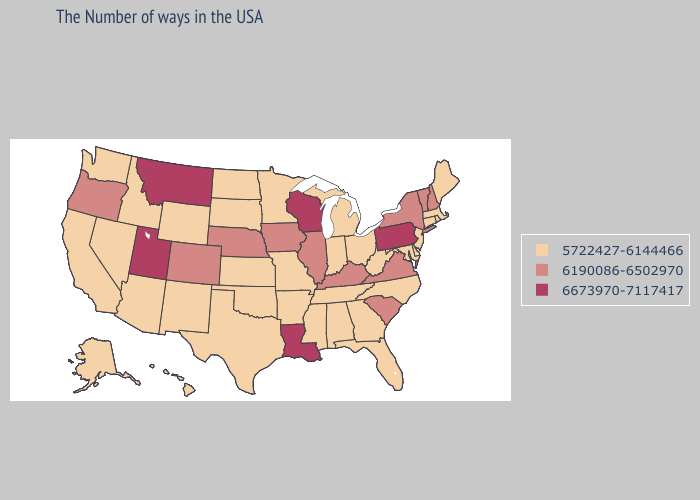What is the value of Oklahoma?
Concise answer only. 5722427-6144466. Name the states that have a value in the range 6190086-6502970?
Write a very short answer. New Hampshire, Vermont, New York, Virginia, South Carolina, Kentucky, Illinois, Iowa, Nebraska, Colorado, Oregon. Does Idaho have a lower value than Rhode Island?
Concise answer only. No. Does Iowa have the lowest value in the USA?
Concise answer only. No. Among the states that border Tennessee , does Virginia have the highest value?
Answer briefly. Yes. Does the first symbol in the legend represent the smallest category?
Keep it brief. Yes. Name the states that have a value in the range 6673970-7117417?
Short answer required. Pennsylvania, Wisconsin, Louisiana, Utah, Montana. What is the highest value in the USA?
Be succinct. 6673970-7117417. What is the lowest value in states that border Missouri?
Concise answer only. 5722427-6144466. Name the states that have a value in the range 6673970-7117417?
Quick response, please. Pennsylvania, Wisconsin, Louisiana, Utah, Montana. Which states have the lowest value in the West?
Be succinct. Wyoming, New Mexico, Arizona, Idaho, Nevada, California, Washington, Alaska, Hawaii. Which states have the lowest value in the West?
Be succinct. Wyoming, New Mexico, Arizona, Idaho, Nevada, California, Washington, Alaska, Hawaii. Among the states that border Vermont , which have the highest value?
Short answer required. New Hampshire, New York. Name the states that have a value in the range 6673970-7117417?
Concise answer only. Pennsylvania, Wisconsin, Louisiana, Utah, Montana. Does Tennessee have the lowest value in the USA?
Give a very brief answer. Yes. 